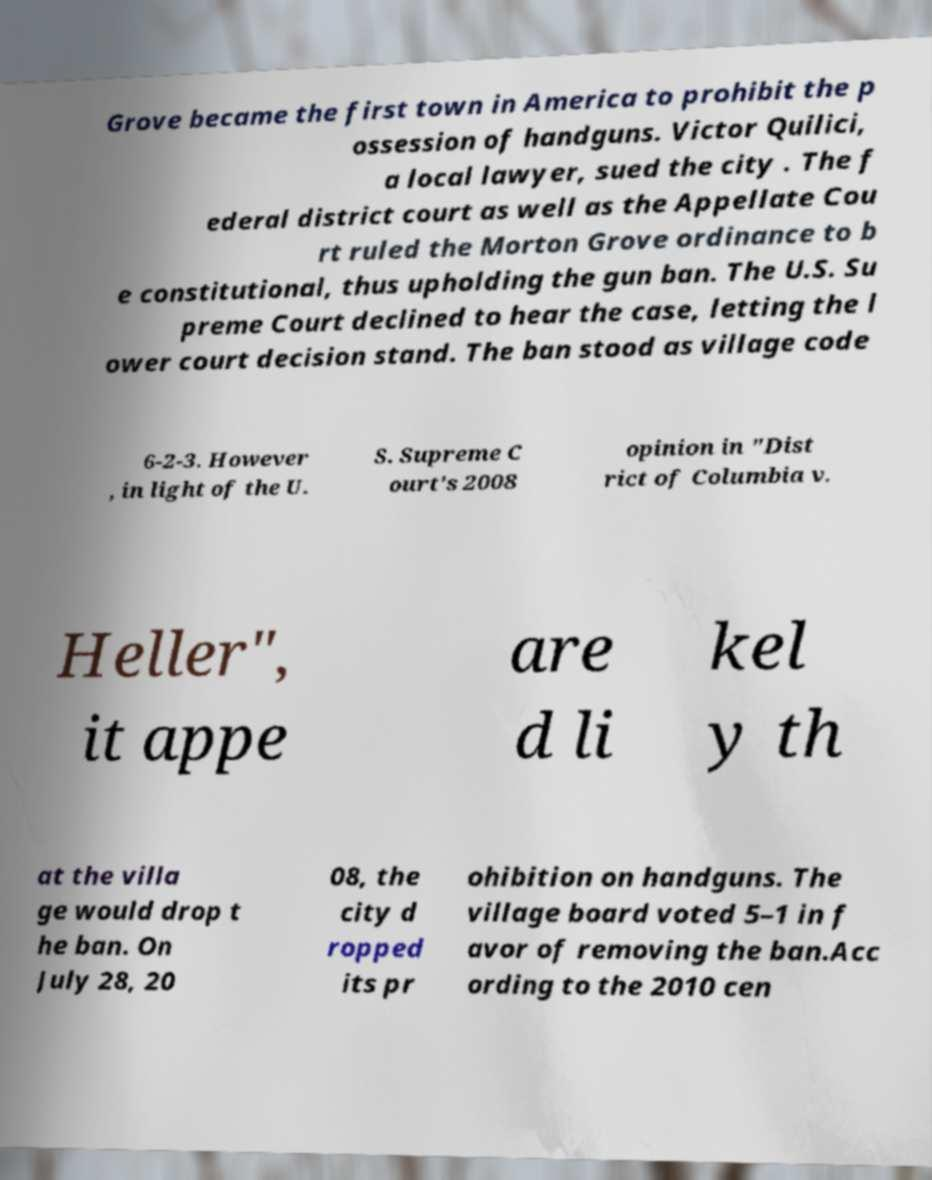Please identify and transcribe the text found in this image. Grove became the first town in America to prohibit the p ossession of handguns. Victor Quilici, a local lawyer, sued the city . The f ederal district court as well as the Appellate Cou rt ruled the Morton Grove ordinance to b e constitutional, thus upholding the gun ban. The U.S. Su preme Court declined to hear the case, letting the l ower court decision stand. The ban stood as village code 6-2-3. However , in light of the U. S. Supreme C ourt's 2008 opinion in "Dist rict of Columbia v. Heller", it appe are d li kel y th at the villa ge would drop t he ban. On July 28, 20 08, the city d ropped its pr ohibition on handguns. The village board voted 5–1 in f avor of removing the ban.Acc ording to the 2010 cen 